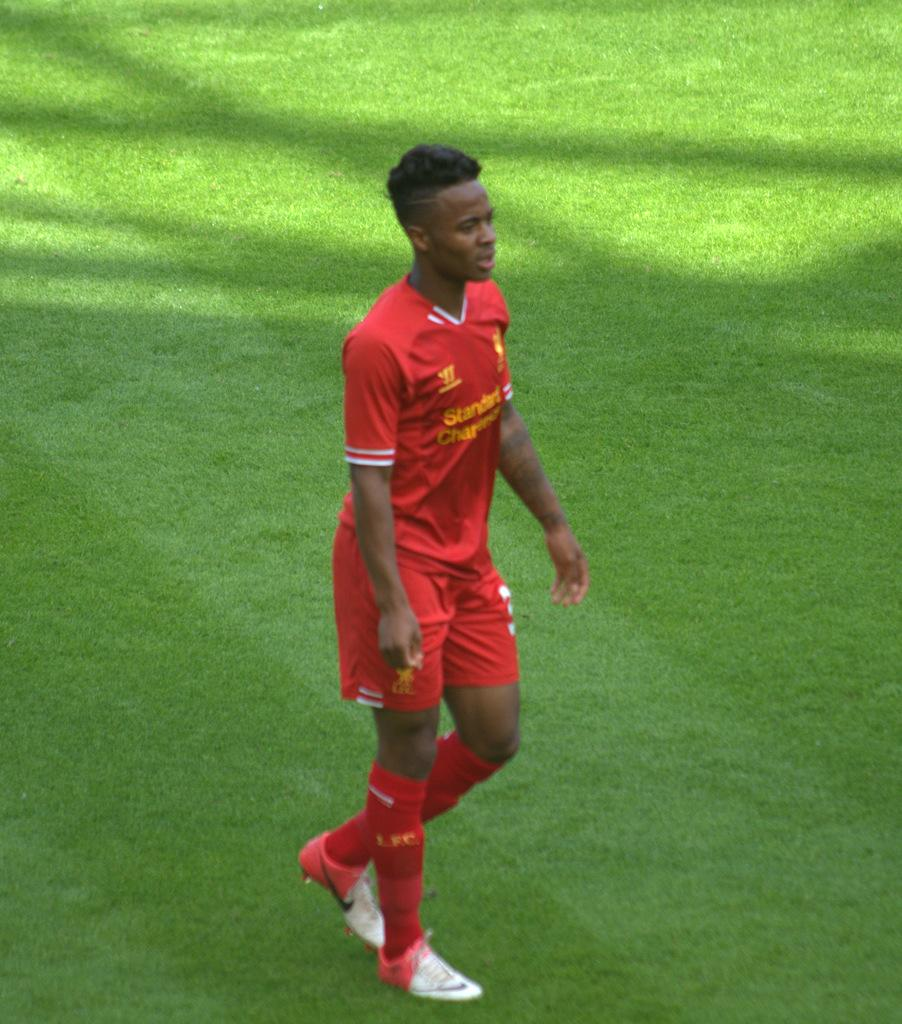What is the main subject of the image? There is a man standing in the image. What is the man standing on? The man is standing on the ground. What color are the clothes the man is wearing? The man is wearing red clothes. What type of footwear is the man wearing? The man is wearing footwear. What type of vegetation is visible in the image? There is grass visible in the image. What type of jeans is the man wearing in the image? The provided facts do not mention jeans, so we cannot determine if the man is wearing jeans or not. 